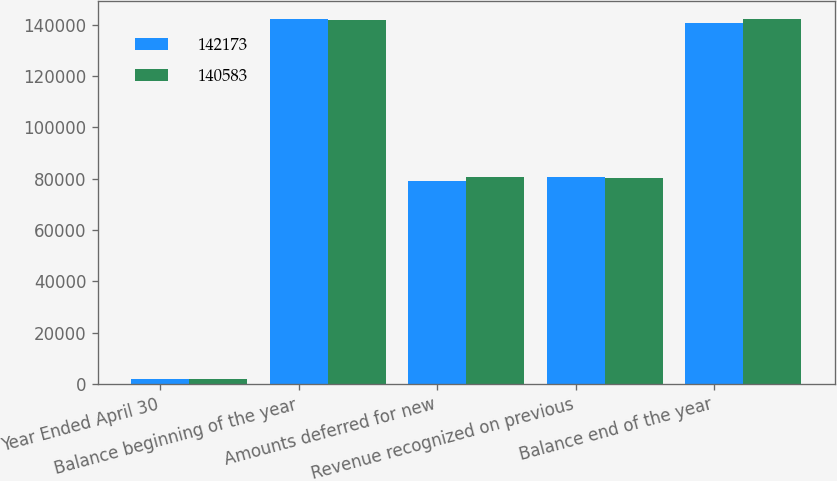<chart> <loc_0><loc_0><loc_500><loc_500><stacked_bar_chart><ecel><fcel>Year Ended April 30<fcel>Balance beginning of the year<fcel>Amounts deferred for new<fcel>Revenue recognized on previous<fcel>Balance end of the year<nl><fcel>142173<fcel>2008<fcel>142173<fcel>78913<fcel>80503<fcel>140583<nl><fcel>140583<fcel>2007<fcel>141684<fcel>80736<fcel>80247<fcel>142173<nl></chart> 